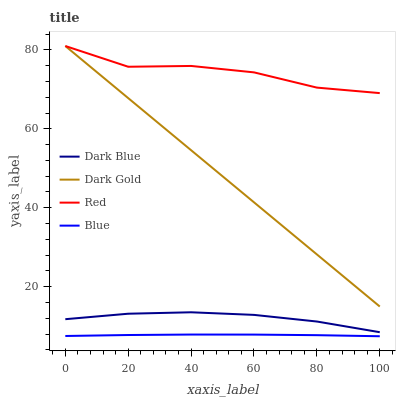Does Blue have the minimum area under the curve?
Answer yes or no. Yes. Does Red have the maximum area under the curve?
Answer yes or no. Yes. Does Dark Blue have the minimum area under the curve?
Answer yes or no. No. Does Dark Blue have the maximum area under the curve?
Answer yes or no. No. Is Dark Gold the smoothest?
Answer yes or no. Yes. Is Red the roughest?
Answer yes or no. Yes. Is Dark Blue the smoothest?
Answer yes or no. No. Is Dark Blue the roughest?
Answer yes or no. No. Does Blue have the lowest value?
Answer yes or no. Yes. Does Dark Blue have the lowest value?
Answer yes or no. No. Does Dark Gold have the highest value?
Answer yes or no. Yes. Does Dark Blue have the highest value?
Answer yes or no. No. Is Dark Blue less than Red?
Answer yes or no. Yes. Is Red greater than Blue?
Answer yes or no. Yes. Does Dark Gold intersect Red?
Answer yes or no. Yes. Is Dark Gold less than Red?
Answer yes or no. No. Is Dark Gold greater than Red?
Answer yes or no. No. Does Dark Blue intersect Red?
Answer yes or no. No. 